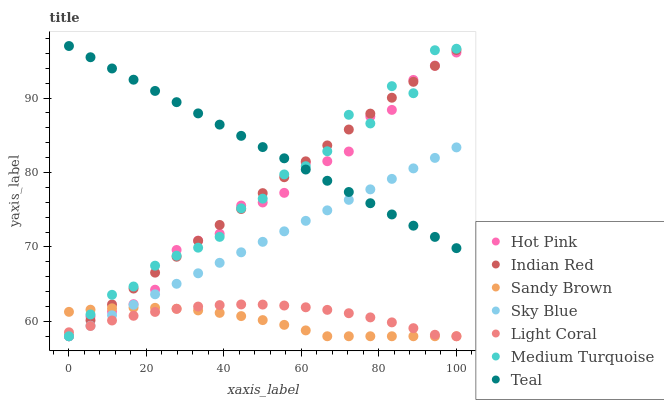Does Sandy Brown have the minimum area under the curve?
Answer yes or no. Yes. Does Teal have the maximum area under the curve?
Answer yes or no. Yes. Does Indian Red have the minimum area under the curve?
Answer yes or no. No. Does Indian Red have the maximum area under the curve?
Answer yes or no. No. Is Indian Red the smoothest?
Answer yes or no. Yes. Is Medium Turquoise the roughest?
Answer yes or no. Yes. Is Hot Pink the smoothest?
Answer yes or no. No. Is Hot Pink the roughest?
Answer yes or no. No. Does Indian Red have the lowest value?
Answer yes or no. Yes. Does Teal have the highest value?
Answer yes or no. Yes. Does Indian Red have the highest value?
Answer yes or no. No. Is Light Coral less than Teal?
Answer yes or no. Yes. Is Teal greater than Sandy Brown?
Answer yes or no. Yes. Does Sky Blue intersect Hot Pink?
Answer yes or no. Yes. Is Sky Blue less than Hot Pink?
Answer yes or no. No. Is Sky Blue greater than Hot Pink?
Answer yes or no. No. Does Light Coral intersect Teal?
Answer yes or no. No. 